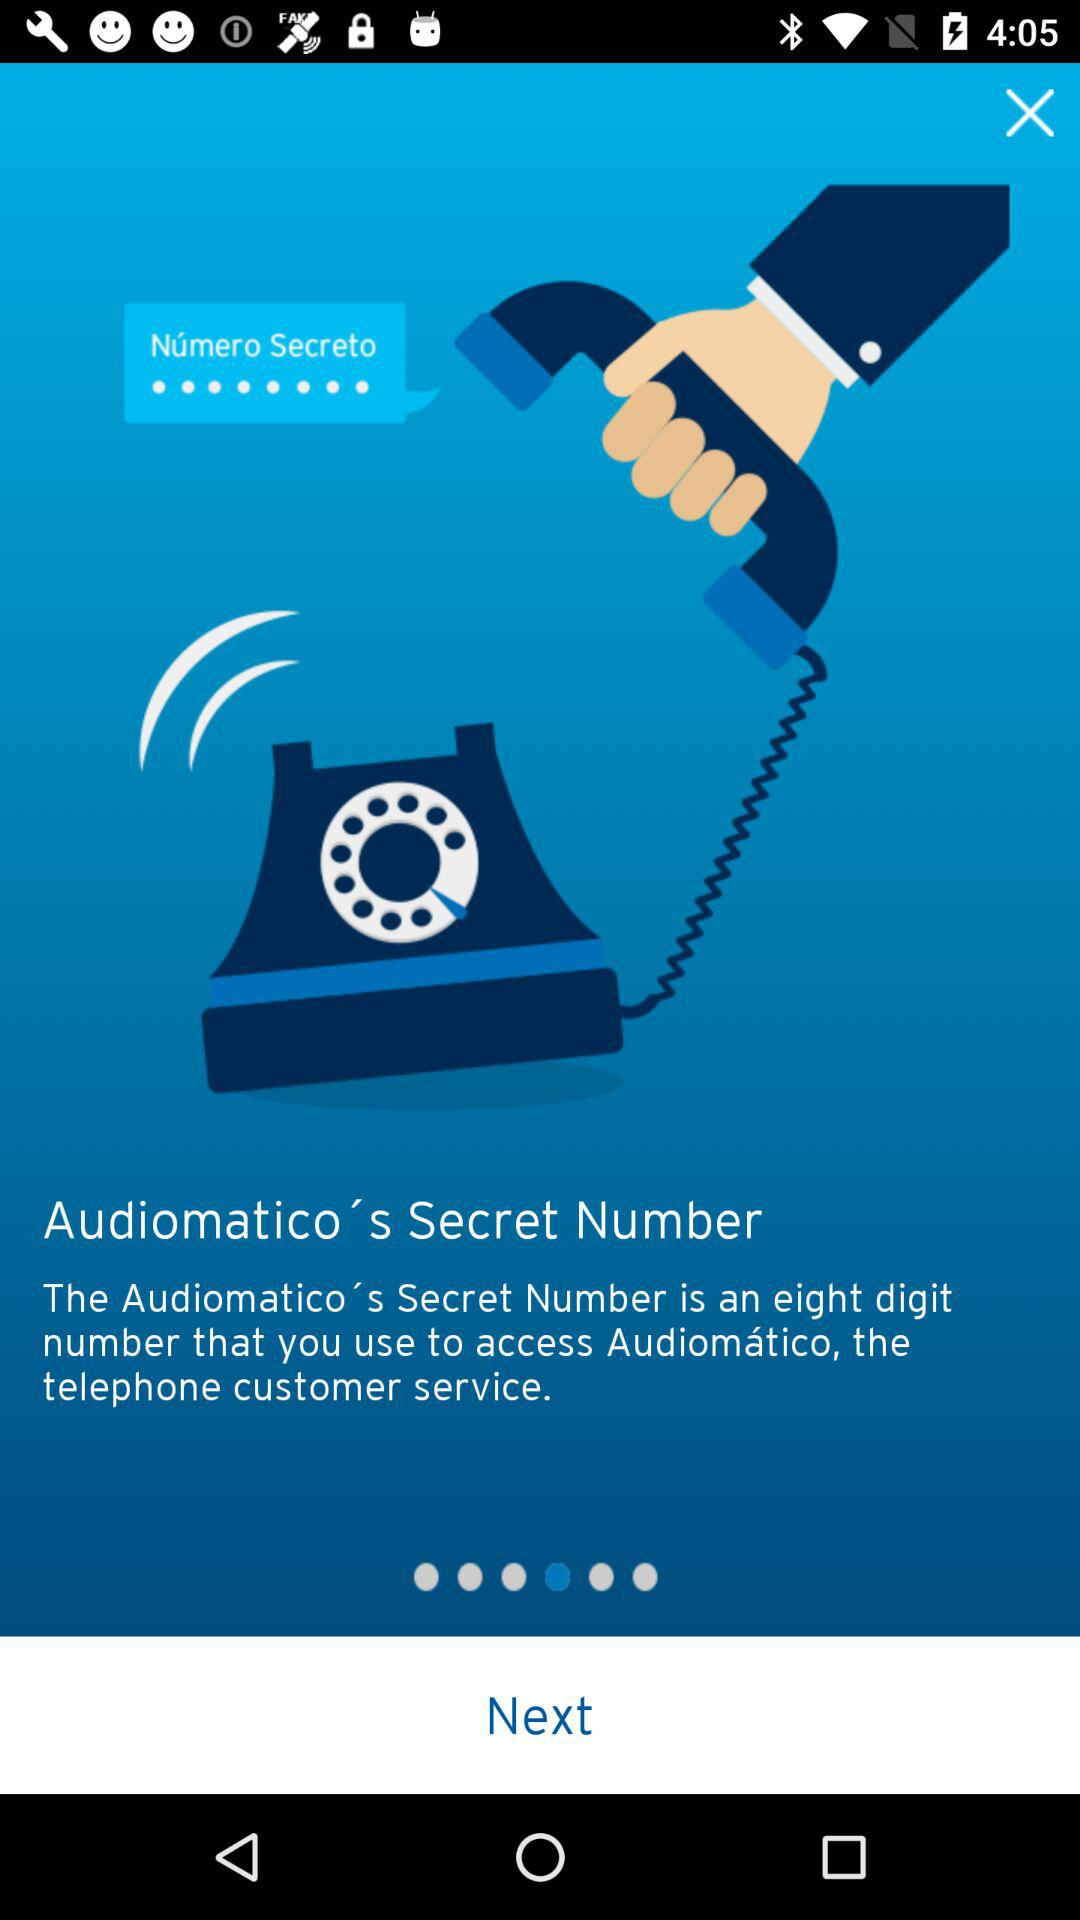How many digits are in the secret number?
Answer the question using a single word or phrase. 8 